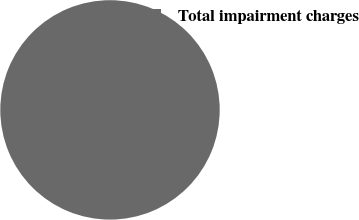Convert chart. <chart><loc_0><loc_0><loc_500><loc_500><pie_chart><fcel>Total impairment charges<nl><fcel>100.0%<nl></chart> 